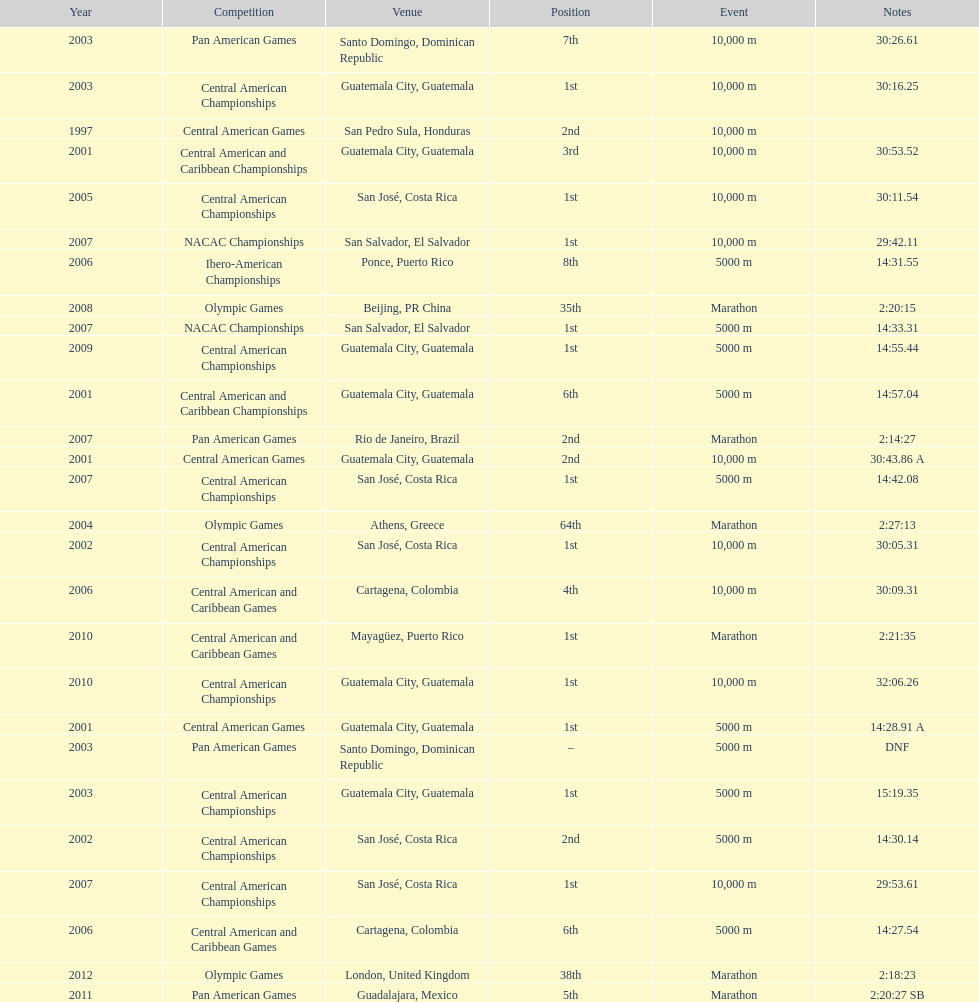Where was the only 64th position held? Athens, Greece. 